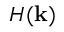<formula> <loc_0><loc_0><loc_500><loc_500>H ( k )</formula> 